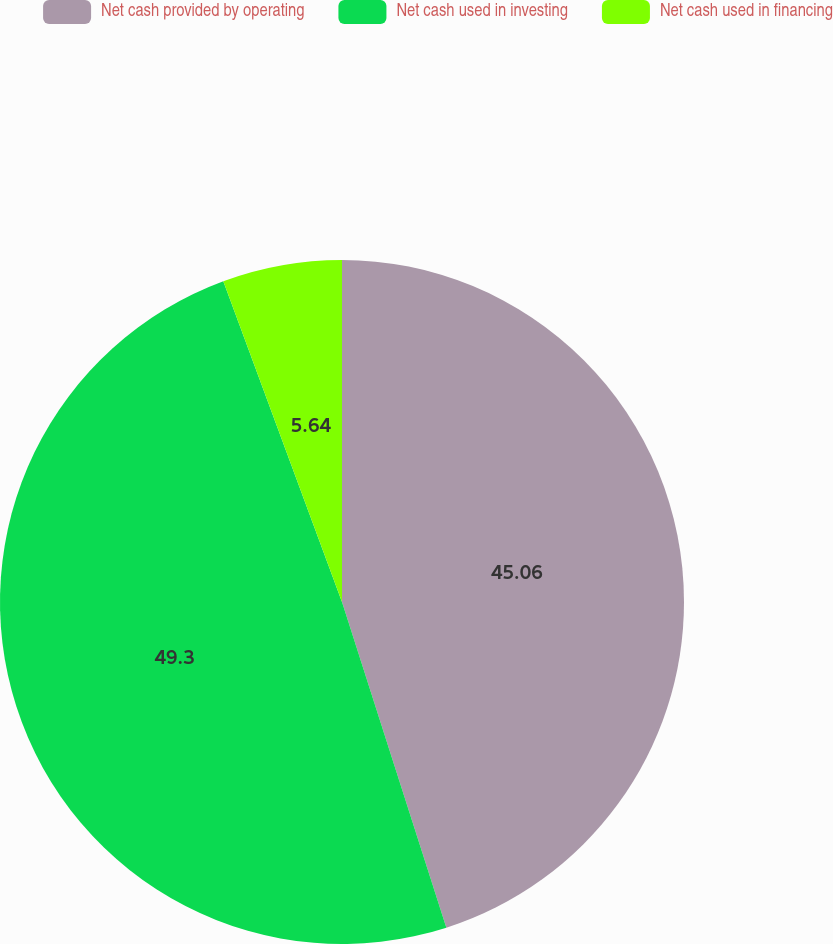Convert chart. <chart><loc_0><loc_0><loc_500><loc_500><pie_chart><fcel>Net cash provided by operating<fcel>Net cash used in investing<fcel>Net cash used in financing<nl><fcel>45.06%<fcel>49.29%<fcel>5.64%<nl></chart> 